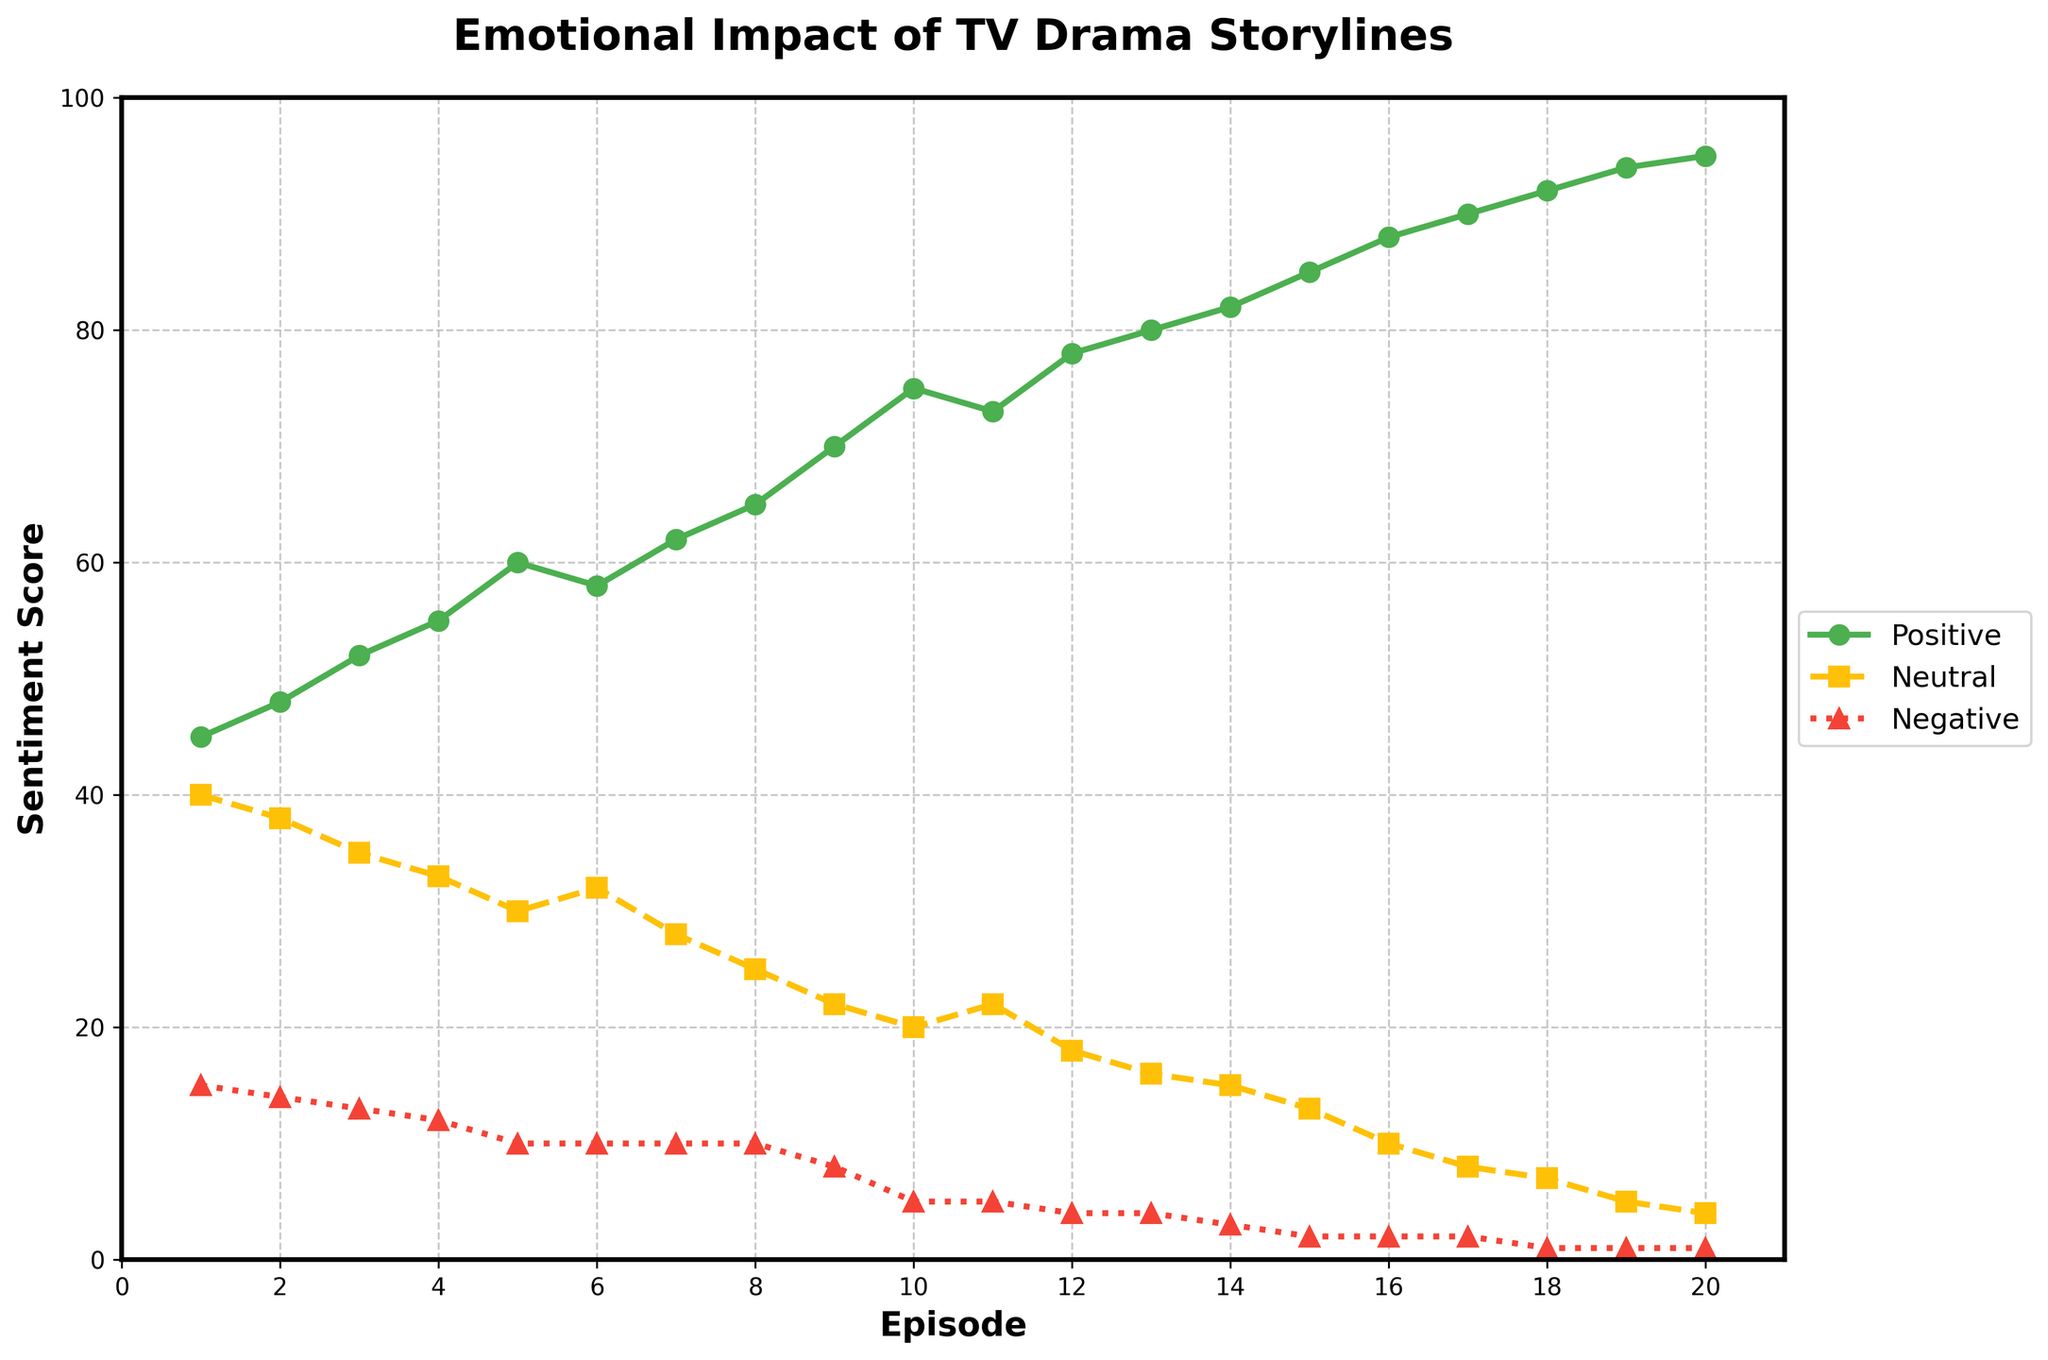What sentiment has the highest scores throughout the episodes? The positive sentiment consistently has the highest scores across all episodes, as indicated by the tallest green line.
Answer: Positive How does the trend of neutral sentiment scores change from episode 1 to episode 20? The neutral sentiment scores start at 40 in episode 1 and decrease gradually to 4 in episode 20, indicating a steady downward trend.
Answer: Decreasing During which episodes is the negative sentiment score constant? The negative sentiment score is constant during episodes 5 to 11 and stays at 10. It is also constant from episode 12 to episode 20 beyond dropping to 4 in episode 12, with a gradual decline later.
Answer: Episodes 5-11 What is the difference in positive sentiment score between episode 1 and episode 20? The positive sentiment score for episode 1 is 45, and for episode 20, it is 95. The difference is calculated as 95 - 45.
Answer: 50 What are the episodes where positive sentiment surpasses 80? The positive sentiment surpasses 80 in episodes 14 through 20.
Answer: Episodes 14-20 Compare the neutral sentiment scores in episode 10 and episode 15. Which one is higher and by how much? The neutral sentiment in episode 10 is 20, and in episode 15, it is 13. Episode 10 is higher, and the difference is 20 - 13.
Answer: Episode 10 by 7 Identify the episode where the negative sentiment score is the lowest. The negative sentiment score is lowest, at 1, in episodes 18, 19, and 20.
Answer: Episodes 18, 19, 20 Calculate the average positive sentiment score for the first 10 episodes. Sum the positive sentiment scores for the first 10 episodes (45 + 48 + 52 + 55 + 60 + 58 + 62 + 65 + 70 + 75 = 590). Divide by 10.
Answer: 59 Describe the overall trend of positive sentiment scores from episode 1 to episode 20. The positive sentiment scores show a clear upward trend from 45 in episode 1 to 95 in episode 20, indicating increasing positive emotional impact over time.
Answer: Increasing trend 